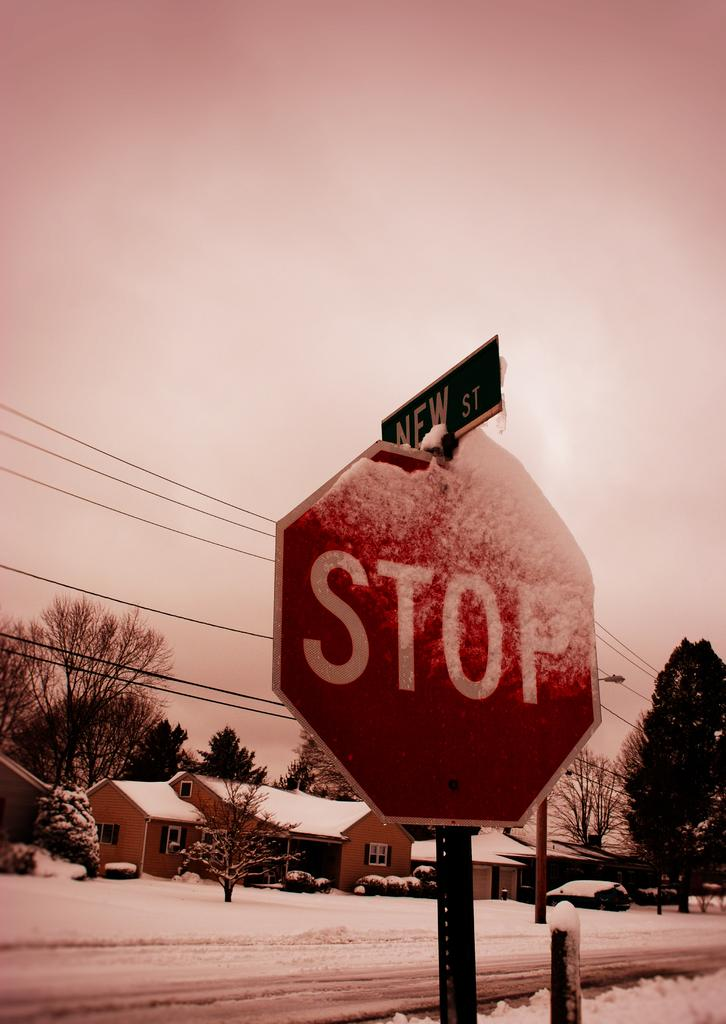<image>
Write a terse but informative summary of the picture. A stop sign in a snowy suburban area. 